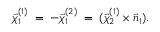Convert formula to latex. <formula><loc_0><loc_0><loc_500><loc_500>\vec { \chi } _ { 1 } ^ { ( 1 ) } \, = \, - \vec { \chi } _ { 1 } ^ { ( 2 ) } \, = \, ( \vec { \chi } _ { 2 } ^ { ( 1 ) } \times \vec { n } _ { 1 } ) .</formula> 